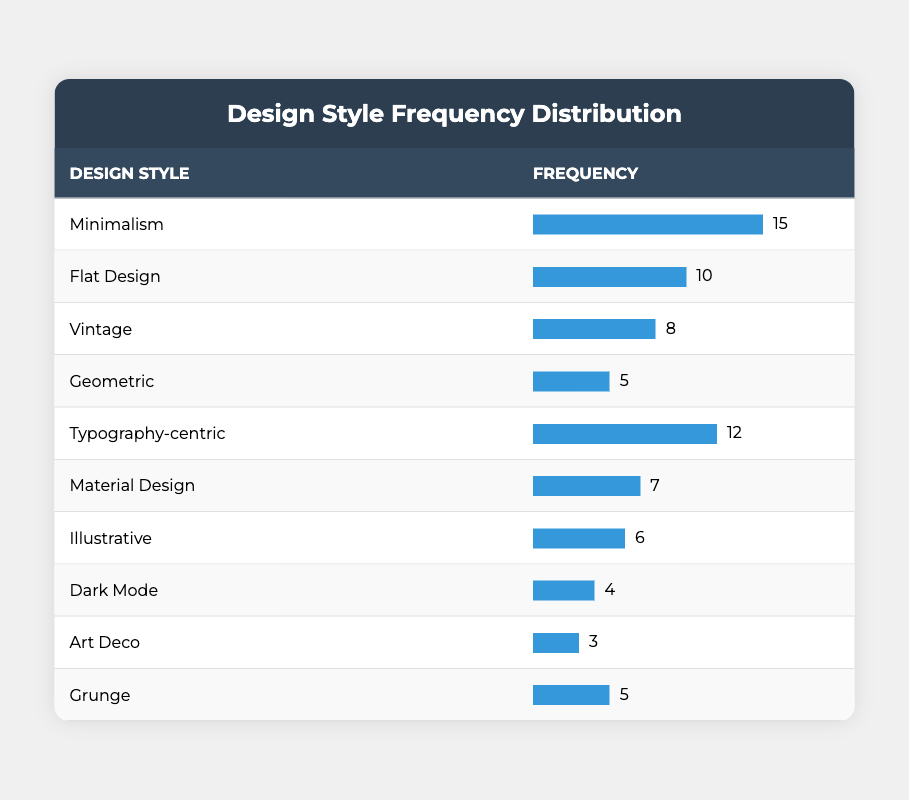What is the most used design style? The table shows that "Minimalism" has a frequency of 15, which is higher than any other design style listed.
Answer: Minimalism How many design styles were used less than 6 times? The styles "Dark Mode" (4), "Art Deco" (3), and "Illustrative" (6) were considered. Only "Dark Mode" and "Art Deco" have frequencies less than 6. Therefore, 2 styles fall into this category.
Answer: 2 What is the total frequency of the top three design styles? The top three styles based on frequency are "Minimalism" (15), "Typography-centric" (12), and "Flat Design" (10). Adding these frequencies gives 15 + 12 + 10 = 37.
Answer: 37 Is "Vintage" used more often than "Geometric"? "Vintage" has a frequency of 8, while "Geometric" has a frequency of 5. Since 8 is greater than 5, "Vintage" is used more often.
Answer: Yes What is the average frequency of all design styles listed? To find the average, sum all frequencies: 15 + 10 + 8 + 5 + 12 + 7 + 6 + 4 + 3 + 5 = 70. There are 10 styles, so the average is 70 / 10 = 7.
Answer: 7 Which design style is least frequently used? The table indicates that "Art Deco" has the least frequency at 3.
Answer: Art Deco What is the difference in frequency between the most and least used design styles? The most used style is "Minimalism" at 15, and the least used is "Art Deco" at 3. The difference is 15 - 3 = 12.
Answer: 12 How many design styles have a frequency of 5 or more? The styles with frequencies of 5 or more are "Minimalism" (15), "Flat Design" (10), "Typography-centric" (12), "Vintage" (8), "Material Design" (7), "Grunge" (5), and "Geometric" (5). Counting these gives a total of 7 styles.
Answer: 7 